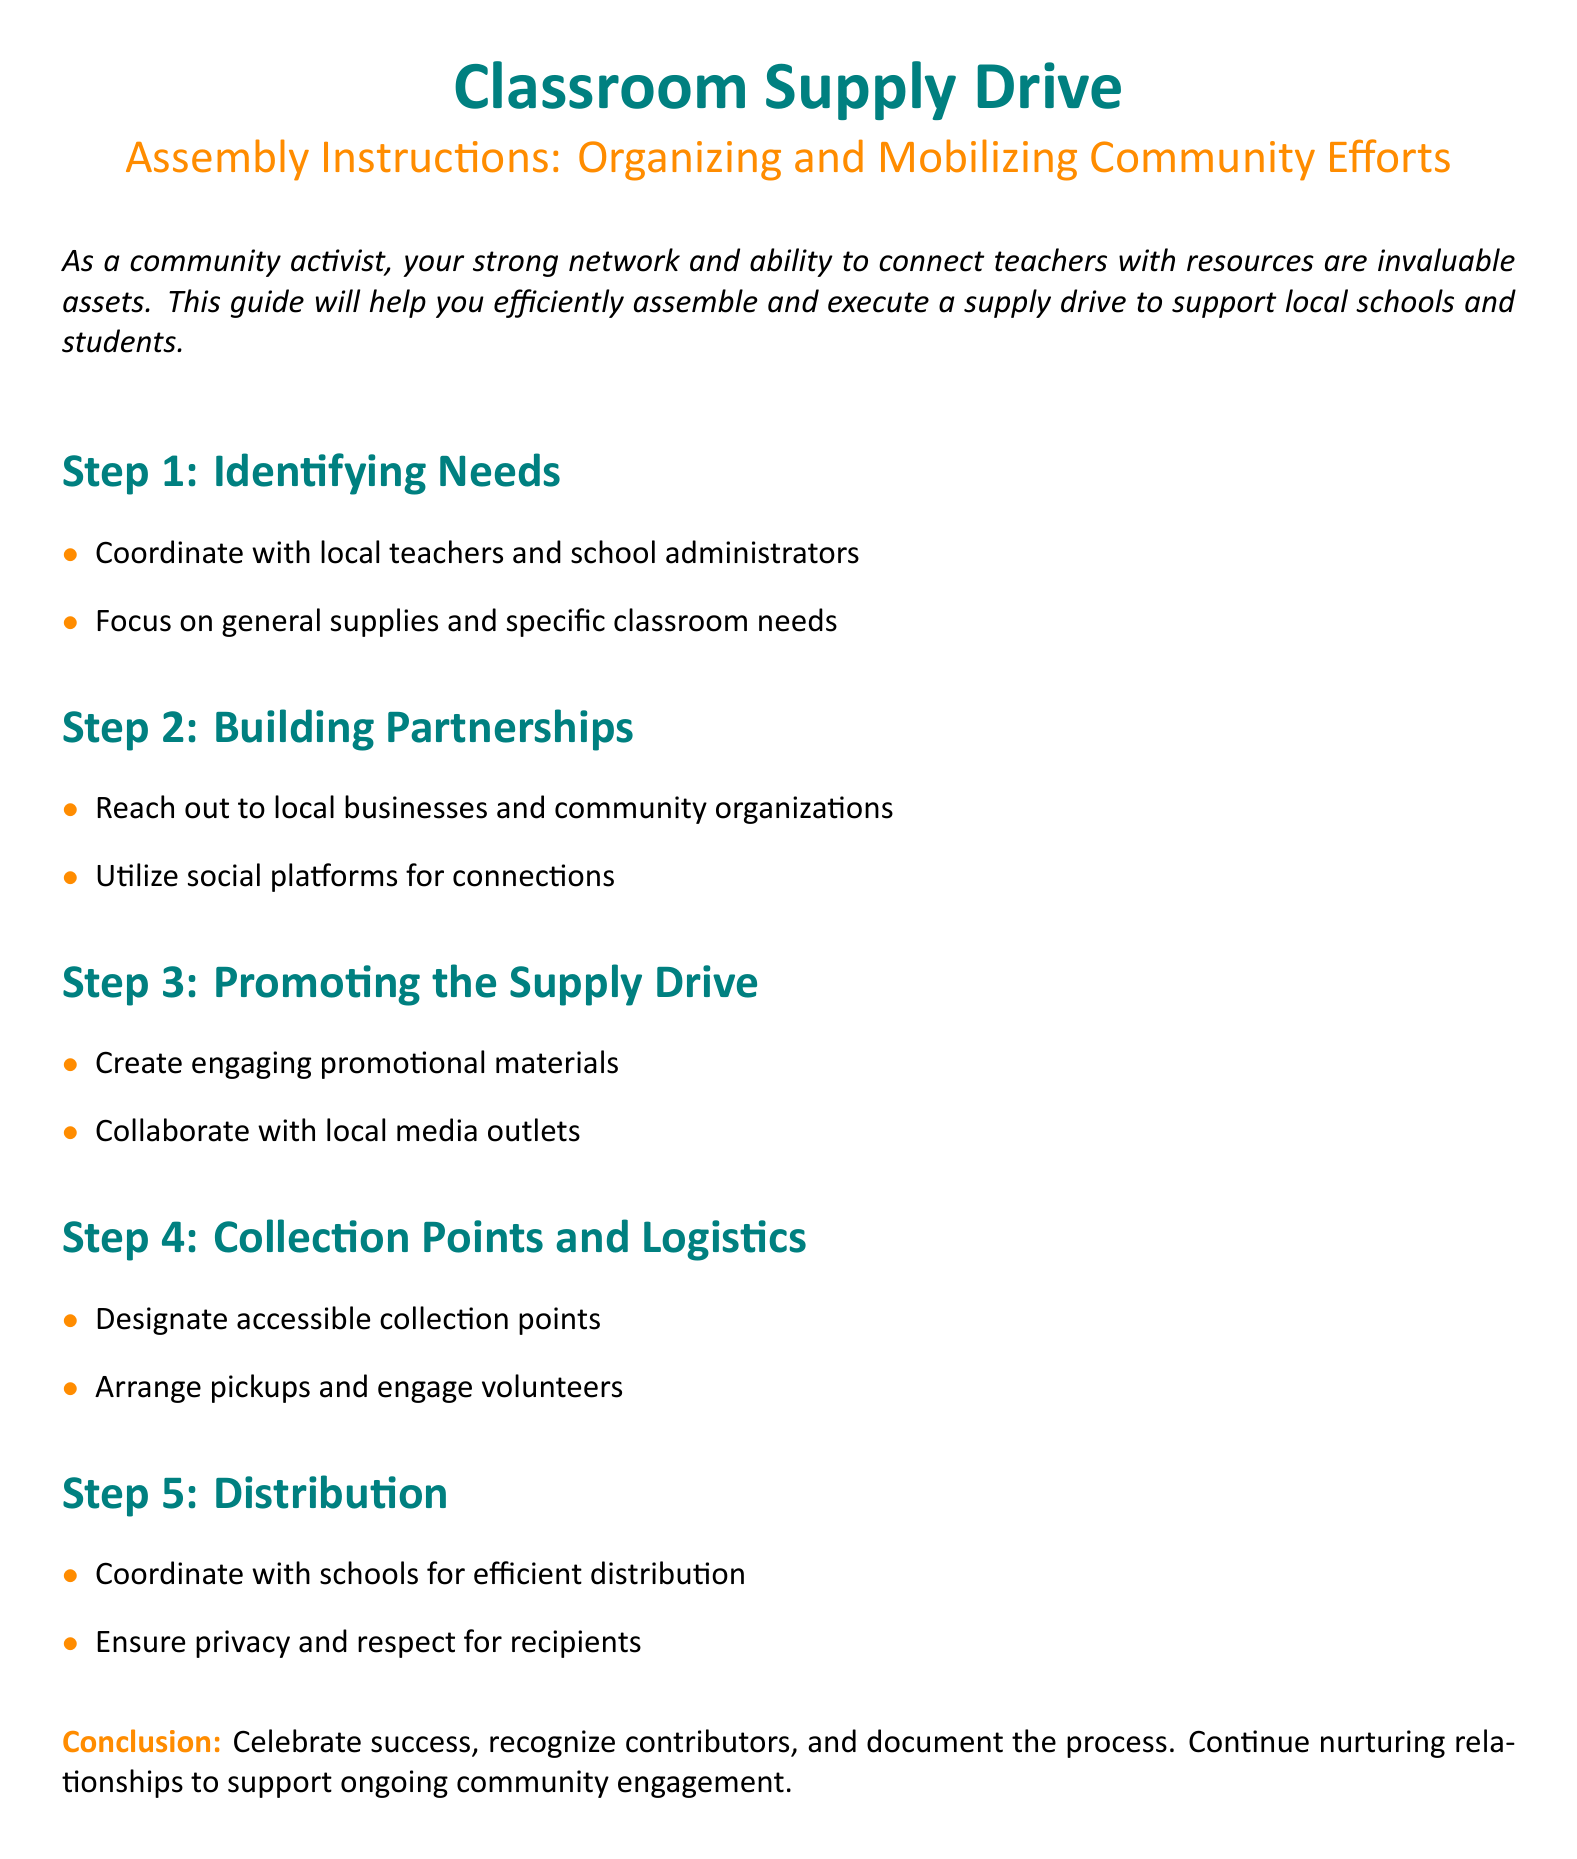What is the primary goal of the document? The document aims to guide community activists in organizing a supply drive for local schools and students.
Answer: Support local schools and students What is the first step in the assembly instructions? The first step outlines the importance of engaging with local educators to identify specific needs for supplies.
Answer: Identifying Needs Which color represents the main titles in the document? The main titles are formatted in a specific shade defined as `maincolor` which corresponds to a particular RGB value.
Answer: RGB(0,128,128) What is the focus when identifying needs? The instructions emphasize collaborating with educators to pinpoint both general and specific requirements for classroom supplies.
Answer: General supplies and specific classroom needs What is mentioned as a way to promote the supply drive? The document suggests creating promotional materials as a method to raise awareness and engagement for the project.
Answer: Create engaging promotional materials How many steps are there in the assembly instructions? The document consists of a series of organized steps that guide the assembly process of the supply drive.
Answer: Five steps What is essential for distribution according to the assembly instructions? The document advises ensuring a respectful and private process when distributing supplies to recipients.
Answer: Ensure privacy and respect for recipients What should be done after recognizing success of the supply drive? After acknowledging success, it is important to document the process and maintain relationships for future efforts.
Answer: Document the process Which section focuses on logistics for the supply drive? The section detailing collection points and logistical arrangements is vital for the smooth operation of the supply drive.
Answer: Collection Points and Logistics 